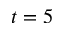Convert formula to latex. <formula><loc_0><loc_0><loc_500><loc_500>t = 5</formula> 